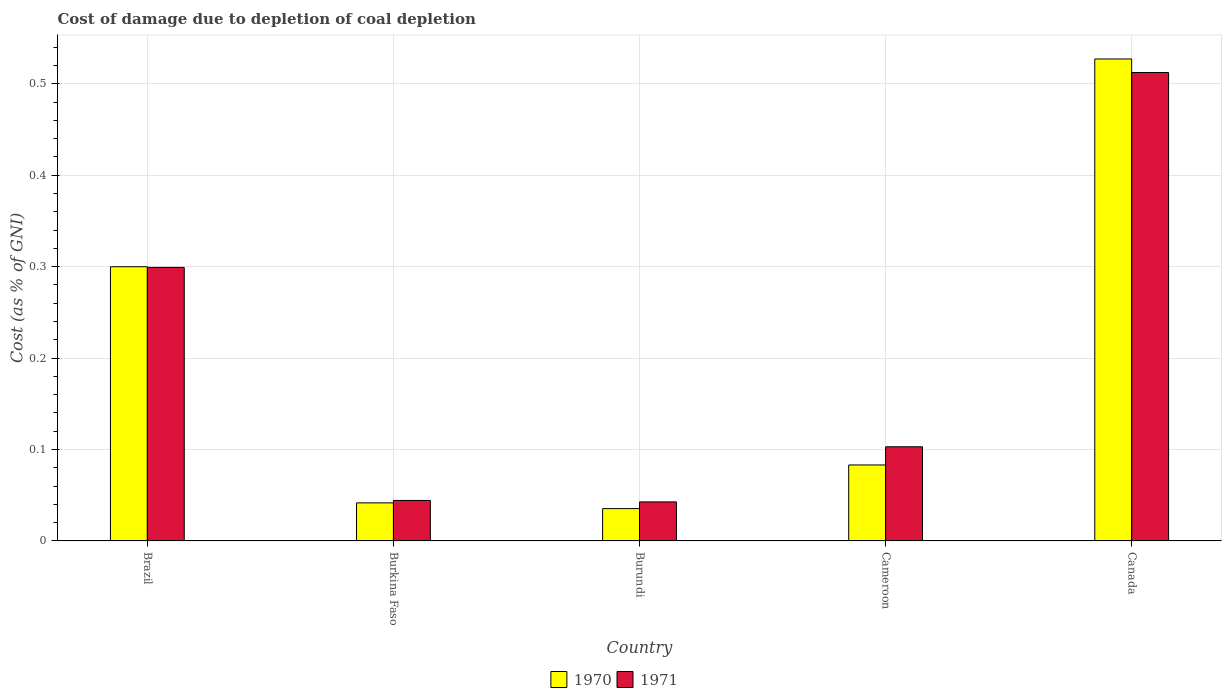How many different coloured bars are there?
Keep it short and to the point. 2. How many groups of bars are there?
Offer a terse response. 5. Are the number of bars per tick equal to the number of legend labels?
Your answer should be compact. Yes. How many bars are there on the 5th tick from the left?
Your answer should be very brief. 2. What is the label of the 2nd group of bars from the left?
Offer a very short reply. Burkina Faso. In how many cases, is the number of bars for a given country not equal to the number of legend labels?
Provide a succinct answer. 0. What is the cost of damage caused due to coal depletion in 1971 in Burundi?
Offer a terse response. 0.04. Across all countries, what is the maximum cost of damage caused due to coal depletion in 1971?
Give a very brief answer. 0.51. Across all countries, what is the minimum cost of damage caused due to coal depletion in 1970?
Offer a very short reply. 0.04. In which country was the cost of damage caused due to coal depletion in 1971 minimum?
Your answer should be compact. Burundi. What is the total cost of damage caused due to coal depletion in 1971 in the graph?
Keep it short and to the point. 1. What is the difference between the cost of damage caused due to coal depletion in 1970 in Burkina Faso and that in Burundi?
Your answer should be compact. 0.01. What is the difference between the cost of damage caused due to coal depletion in 1971 in Burkina Faso and the cost of damage caused due to coal depletion in 1970 in Canada?
Your answer should be very brief. -0.48. What is the average cost of damage caused due to coal depletion in 1971 per country?
Ensure brevity in your answer.  0.2. What is the difference between the cost of damage caused due to coal depletion of/in 1971 and cost of damage caused due to coal depletion of/in 1970 in Cameroon?
Your answer should be very brief. 0.02. In how many countries, is the cost of damage caused due to coal depletion in 1971 greater than 0.26 %?
Ensure brevity in your answer.  2. What is the ratio of the cost of damage caused due to coal depletion in 1970 in Burkina Faso to that in Cameroon?
Ensure brevity in your answer.  0.5. What is the difference between the highest and the second highest cost of damage caused due to coal depletion in 1971?
Your answer should be very brief. 0.41. What is the difference between the highest and the lowest cost of damage caused due to coal depletion in 1971?
Offer a terse response. 0.47. In how many countries, is the cost of damage caused due to coal depletion in 1971 greater than the average cost of damage caused due to coal depletion in 1971 taken over all countries?
Your answer should be compact. 2. How many countries are there in the graph?
Offer a terse response. 5. Does the graph contain grids?
Provide a succinct answer. Yes. How are the legend labels stacked?
Your answer should be compact. Horizontal. What is the title of the graph?
Provide a succinct answer. Cost of damage due to depletion of coal depletion. Does "1998" appear as one of the legend labels in the graph?
Keep it short and to the point. No. What is the label or title of the X-axis?
Keep it short and to the point. Country. What is the label or title of the Y-axis?
Provide a succinct answer. Cost (as % of GNI). What is the Cost (as % of GNI) of 1970 in Brazil?
Offer a terse response. 0.3. What is the Cost (as % of GNI) in 1971 in Brazil?
Offer a very short reply. 0.3. What is the Cost (as % of GNI) in 1970 in Burkina Faso?
Give a very brief answer. 0.04. What is the Cost (as % of GNI) of 1971 in Burkina Faso?
Your answer should be compact. 0.04. What is the Cost (as % of GNI) in 1970 in Burundi?
Your answer should be compact. 0.04. What is the Cost (as % of GNI) of 1971 in Burundi?
Provide a succinct answer. 0.04. What is the Cost (as % of GNI) in 1970 in Cameroon?
Keep it short and to the point. 0.08. What is the Cost (as % of GNI) of 1971 in Cameroon?
Offer a terse response. 0.1. What is the Cost (as % of GNI) in 1970 in Canada?
Make the answer very short. 0.53. What is the Cost (as % of GNI) in 1971 in Canada?
Provide a succinct answer. 0.51. Across all countries, what is the maximum Cost (as % of GNI) in 1970?
Ensure brevity in your answer.  0.53. Across all countries, what is the maximum Cost (as % of GNI) in 1971?
Keep it short and to the point. 0.51. Across all countries, what is the minimum Cost (as % of GNI) in 1970?
Offer a very short reply. 0.04. Across all countries, what is the minimum Cost (as % of GNI) in 1971?
Offer a very short reply. 0.04. What is the total Cost (as % of GNI) in 1970 in the graph?
Your answer should be compact. 0.99. What is the total Cost (as % of GNI) of 1971 in the graph?
Your answer should be very brief. 1. What is the difference between the Cost (as % of GNI) of 1970 in Brazil and that in Burkina Faso?
Your answer should be compact. 0.26. What is the difference between the Cost (as % of GNI) of 1971 in Brazil and that in Burkina Faso?
Ensure brevity in your answer.  0.25. What is the difference between the Cost (as % of GNI) of 1970 in Brazil and that in Burundi?
Provide a succinct answer. 0.26. What is the difference between the Cost (as % of GNI) of 1971 in Brazil and that in Burundi?
Give a very brief answer. 0.26. What is the difference between the Cost (as % of GNI) of 1970 in Brazil and that in Cameroon?
Keep it short and to the point. 0.22. What is the difference between the Cost (as % of GNI) in 1971 in Brazil and that in Cameroon?
Provide a succinct answer. 0.2. What is the difference between the Cost (as % of GNI) of 1970 in Brazil and that in Canada?
Your response must be concise. -0.23. What is the difference between the Cost (as % of GNI) of 1971 in Brazil and that in Canada?
Your answer should be very brief. -0.21. What is the difference between the Cost (as % of GNI) of 1970 in Burkina Faso and that in Burundi?
Make the answer very short. 0.01. What is the difference between the Cost (as % of GNI) in 1971 in Burkina Faso and that in Burundi?
Give a very brief answer. 0. What is the difference between the Cost (as % of GNI) of 1970 in Burkina Faso and that in Cameroon?
Provide a short and direct response. -0.04. What is the difference between the Cost (as % of GNI) in 1971 in Burkina Faso and that in Cameroon?
Provide a short and direct response. -0.06. What is the difference between the Cost (as % of GNI) of 1970 in Burkina Faso and that in Canada?
Keep it short and to the point. -0.49. What is the difference between the Cost (as % of GNI) of 1971 in Burkina Faso and that in Canada?
Provide a succinct answer. -0.47. What is the difference between the Cost (as % of GNI) in 1970 in Burundi and that in Cameroon?
Offer a very short reply. -0.05. What is the difference between the Cost (as % of GNI) of 1971 in Burundi and that in Cameroon?
Keep it short and to the point. -0.06. What is the difference between the Cost (as % of GNI) of 1970 in Burundi and that in Canada?
Make the answer very short. -0.49. What is the difference between the Cost (as % of GNI) of 1971 in Burundi and that in Canada?
Keep it short and to the point. -0.47. What is the difference between the Cost (as % of GNI) in 1970 in Cameroon and that in Canada?
Your answer should be compact. -0.44. What is the difference between the Cost (as % of GNI) in 1971 in Cameroon and that in Canada?
Make the answer very short. -0.41. What is the difference between the Cost (as % of GNI) in 1970 in Brazil and the Cost (as % of GNI) in 1971 in Burkina Faso?
Give a very brief answer. 0.26. What is the difference between the Cost (as % of GNI) in 1970 in Brazil and the Cost (as % of GNI) in 1971 in Burundi?
Give a very brief answer. 0.26. What is the difference between the Cost (as % of GNI) of 1970 in Brazil and the Cost (as % of GNI) of 1971 in Cameroon?
Give a very brief answer. 0.2. What is the difference between the Cost (as % of GNI) of 1970 in Brazil and the Cost (as % of GNI) of 1971 in Canada?
Your answer should be very brief. -0.21. What is the difference between the Cost (as % of GNI) of 1970 in Burkina Faso and the Cost (as % of GNI) of 1971 in Burundi?
Keep it short and to the point. -0. What is the difference between the Cost (as % of GNI) of 1970 in Burkina Faso and the Cost (as % of GNI) of 1971 in Cameroon?
Offer a very short reply. -0.06. What is the difference between the Cost (as % of GNI) of 1970 in Burkina Faso and the Cost (as % of GNI) of 1971 in Canada?
Give a very brief answer. -0.47. What is the difference between the Cost (as % of GNI) in 1970 in Burundi and the Cost (as % of GNI) in 1971 in Cameroon?
Keep it short and to the point. -0.07. What is the difference between the Cost (as % of GNI) of 1970 in Burundi and the Cost (as % of GNI) of 1971 in Canada?
Your response must be concise. -0.48. What is the difference between the Cost (as % of GNI) in 1970 in Cameroon and the Cost (as % of GNI) in 1971 in Canada?
Ensure brevity in your answer.  -0.43. What is the average Cost (as % of GNI) in 1970 per country?
Ensure brevity in your answer.  0.2. What is the average Cost (as % of GNI) in 1971 per country?
Provide a short and direct response. 0.2. What is the difference between the Cost (as % of GNI) in 1970 and Cost (as % of GNI) in 1971 in Brazil?
Your response must be concise. 0. What is the difference between the Cost (as % of GNI) of 1970 and Cost (as % of GNI) of 1971 in Burkina Faso?
Provide a succinct answer. -0. What is the difference between the Cost (as % of GNI) in 1970 and Cost (as % of GNI) in 1971 in Burundi?
Provide a short and direct response. -0.01. What is the difference between the Cost (as % of GNI) in 1970 and Cost (as % of GNI) in 1971 in Cameroon?
Provide a short and direct response. -0.02. What is the difference between the Cost (as % of GNI) of 1970 and Cost (as % of GNI) of 1971 in Canada?
Provide a short and direct response. 0.01. What is the ratio of the Cost (as % of GNI) in 1970 in Brazil to that in Burkina Faso?
Keep it short and to the point. 7.2. What is the ratio of the Cost (as % of GNI) in 1971 in Brazil to that in Burkina Faso?
Keep it short and to the point. 6.76. What is the ratio of the Cost (as % of GNI) of 1970 in Brazil to that in Burundi?
Your answer should be very brief. 8.48. What is the ratio of the Cost (as % of GNI) in 1971 in Brazil to that in Burundi?
Your answer should be very brief. 7.01. What is the ratio of the Cost (as % of GNI) in 1970 in Brazil to that in Cameroon?
Ensure brevity in your answer.  3.61. What is the ratio of the Cost (as % of GNI) in 1971 in Brazil to that in Cameroon?
Provide a short and direct response. 2.9. What is the ratio of the Cost (as % of GNI) of 1970 in Brazil to that in Canada?
Your response must be concise. 0.57. What is the ratio of the Cost (as % of GNI) of 1971 in Brazil to that in Canada?
Offer a very short reply. 0.58. What is the ratio of the Cost (as % of GNI) of 1970 in Burkina Faso to that in Burundi?
Keep it short and to the point. 1.18. What is the ratio of the Cost (as % of GNI) in 1970 in Burkina Faso to that in Cameroon?
Offer a terse response. 0.5. What is the ratio of the Cost (as % of GNI) in 1971 in Burkina Faso to that in Cameroon?
Make the answer very short. 0.43. What is the ratio of the Cost (as % of GNI) of 1970 in Burkina Faso to that in Canada?
Your response must be concise. 0.08. What is the ratio of the Cost (as % of GNI) in 1971 in Burkina Faso to that in Canada?
Offer a terse response. 0.09. What is the ratio of the Cost (as % of GNI) in 1970 in Burundi to that in Cameroon?
Your answer should be very brief. 0.43. What is the ratio of the Cost (as % of GNI) of 1971 in Burundi to that in Cameroon?
Your response must be concise. 0.41. What is the ratio of the Cost (as % of GNI) of 1970 in Burundi to that in Canada?
Give a very brief answer. 0.07. What is the ratio of the Cost (as % of GNI) in 1971 in Burundi to that in Canada?
Offer a terse response. 0.08. What is the ratio of the Cost (as % of GNI) in 1970 in Cameroon to that in Canada?
Your answer should be compact. 0.16. What is the ratio of the Cost (as % of GNI) of 1971 in Cameroon to that in Canada?
Your response must be concise. 0.2. What is the difference between the highest and the second highest Cost (as % of GNI) in 1970?
Provide a short and direct response. 0.23. What is the difference between the highest and the second highest Cost (as % of GNI) of 1971?
Your answer should be very brief. 0.21. What is the difference between the highest and the lowest Cost (as % of GNI) in 1970?
Make the answer very short. 0.49. What is the difference between the highest and the lowest Cost (as % of GNI) of 1971?
Ensure brevity in your answer.  0.47. 